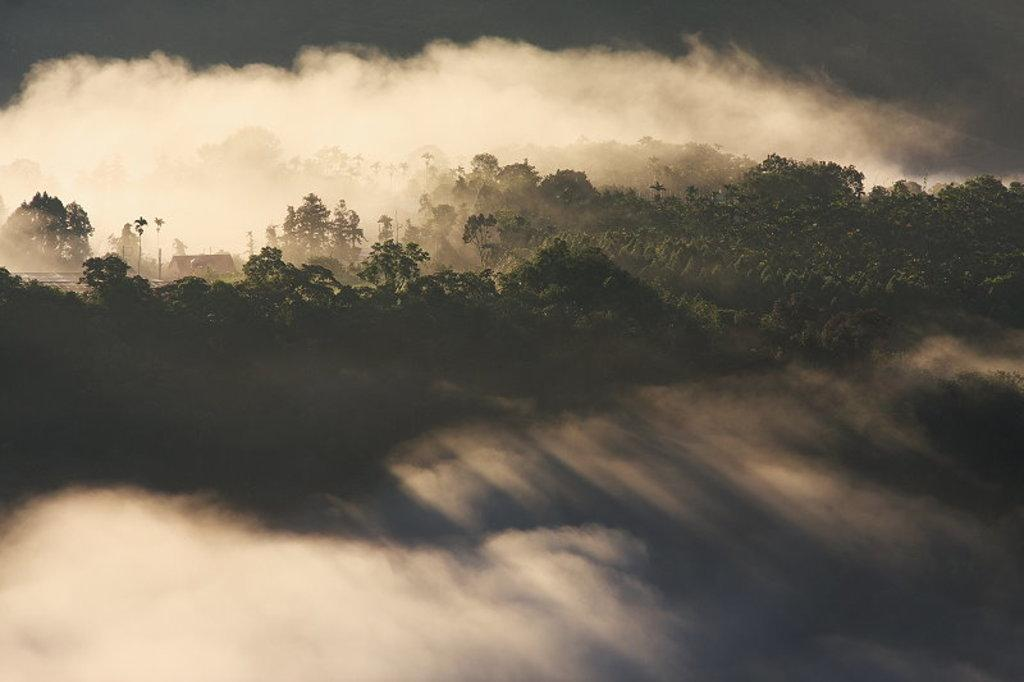What is the main subject in the center of the image? There are trees in the center of the image. Do the trees in the image have the ability to exist in outer space? The trees in the image are on Earth, and there is no indication that they have the ability to exist in outer space. 